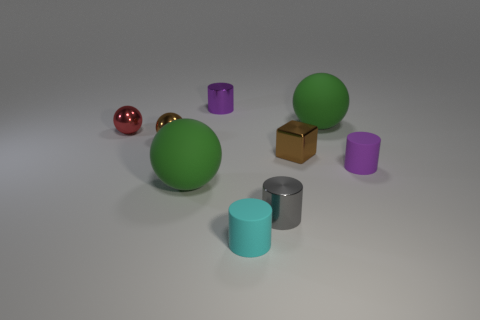What is the material of the tiny thing that is on the right side of the small metal cube?
Make the answer very short. Rubber. There is a rubber ball in front of the big ball on the right side of the green sphere left of the tiny cyan object; what is its color?
Provide a short and direct response. Green. What is the color of the block that is the same size as the gray metal cylinder?
Ensure brevity in your answer.  Brown. How many shiny objects are either tiny things or gray objects?
Offer a very short reply. 5. There is another small sphere that is made of the same material as the brown ball; what is its color?
Keep it short and to the point. Red. What is the material of the small thing behind the big sphere to the right of the gray cylinder?
Give a very brief answer. Metal. How many objects are either green rubber objects in front of the purple matte cylinder or big spheres that are behind the shiny cube?
Provide a short and direct response. 2. How big is the brown metallic object left of the large green ball on the left side of the small cylinder behind the tiny cube?
Keep it short and to the point. Small. Are there an equal number of small metal balls that are behind the brown metal ball and purple shiny cylinders?
Offer a terse response. Yes. Does the tiny red metallic thing have the same shape as the tiny purple thing that is behind the tiny brown block?
Give a very brief answer. No. 